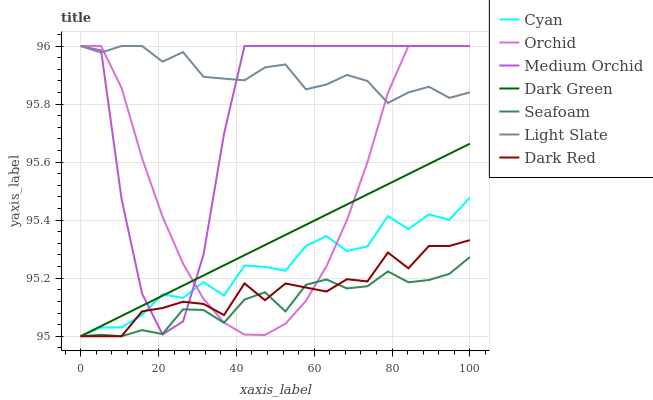Does Seafoam have the minimum area under the curve?
Answer yes or no. Yes. Does Light Slate have the maximum area under the curve?
Answer yes or no. Yes. Does Dark Red have the minimum area under the curve?
Answer yes or no. No. Does Dark Red have the maximum area under the curve?
Answer yes or no. No. Is Dark Green the smoothest?
Answer yes or no. Yes. Is Medium Orchid the roughest?
Answer yes or no. Yes. Is Dark Red the smoothest?
Answer yes or no. No. Is Dark Red the roughest?
Answer yes or no. No. Does Dark Red have the lowest value?
Answer yes or no. Yes. Does Medium Orchid have the lowest value?
Answer yes or no. No. Does Orchid have the highest value?
Answer yes or no. Yes. Does Dark Red have the highest value?
Answer yes or no. No. Is Dark Green less than Light Slate?
Answer yes or no. Yes. Is Light Slate greater than Dark Green?
Answer yes or no. Yes. Does Dark Green intersect Medium Orchid?
Answer yes or no. Yes. Is Dark Green less than Medium Orchid?
Answer yes or no. No. Is Dark Green greater than Medium Orchid?
Answer yes or no. No. Does Dark Green intersect Light Slate?
Answer yes or no. No. 